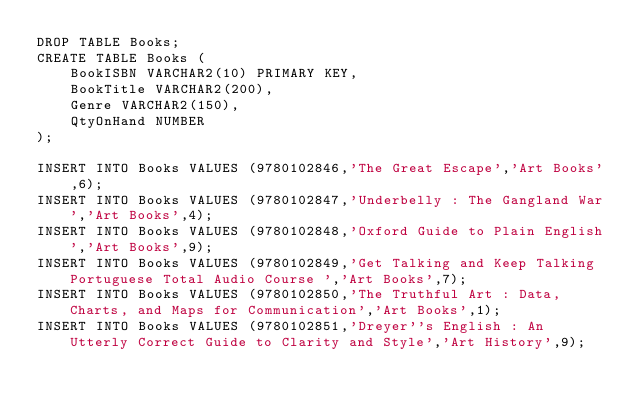<code> <loc_0><loc_0><loc_500><loc_500><_SQL_>DROP TABLE Books;
CREATE TABLE Books (
	BookISBN VARCHAR2(10) PRIMARY KEY,
	BookTitle VARCHAR2(200),
	Genre VARCHAR2(150),
	QtyOnHand NUMBER
);

INSERT INTO Books VALUES (9780102846,'The Great Escape','Art Books',6);
INSERT INTO Books VALUES (9780102847,'Underbelly : The Gangland War','Art Books',4);
INSERT INTO Books VALUES (9780102848,'Oxford Guide to Plain English','Art Books',9);
INSERT INTO Books VALUES (9780102849,'Get Talking and Keep Talking Portuguese Total Audio Course ','Art Books',7);
INSERT INTO Books VALUES (9780102850,'The Truthful Art : Data, Charts, and Maps for Communication','Art Books',1);
INSERT INTO Books VALUES (9780102851,'Dreyer''s English : An Utterly Correct Guide to Clarity and Style','Art History',9);</code> 